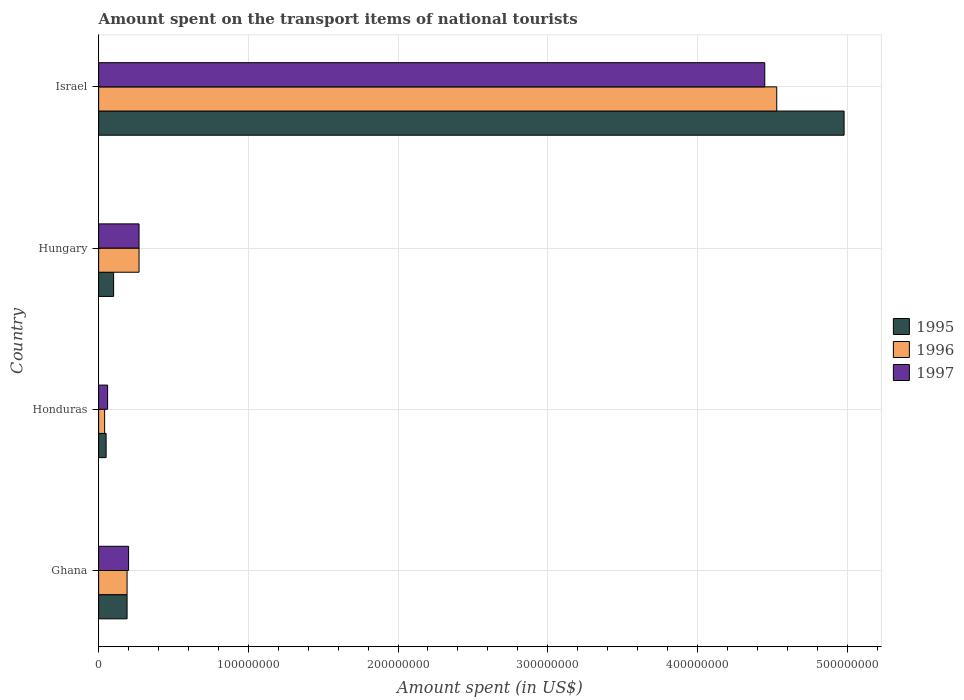How many different coloured bars are there?
Your answer should be compact. 3. How many bars are there on the 3rd tick from the top?
Give a very brief answer. 3. What is the label of the 4th group of bars from the top?
Provide a succinct answer. Ghana. In how many cases, is the number of bars for a given country not equal to the number of legend labels?
Offer a terse response. 0. What is the amount spent on the transport items of national tourists in 1996 in Honduras?
Provide a short and direct response. 4.00e+06. Across all countries, what is the maximum amount spent on the transport items of national tourists in 1997?
Provide a succinct answer. 4.45e+08. In which country was the amount spent on the transport items of national tourists in 1995 minimum?
Your response must be concise. Honduras. What is the total amount spent on the transport items of national tourists in 1996 in the graph?
Ensure brevity in your answer.  5.03e+08. What is the difference between the amount spent on the transport items of national tourists in 1996 in Ghana and that in Honduras?
Provide a short and direct response. 1.50e+07. What is the difference between the amount spent on the transport items of national tourists in 1996 in Honduras and the amount spent on the transport items of national tourists in 1995 in Ghana?
Your response must be concise. -1.50e+07. What is the average amount spent on the transport items of national tourists in 1996 per country?
Your answer should be compact. 1.26e+08. What is the ratio of the amount spent on the transport items of national tourists in 1997 in Honduras to that in Israel?
Offer a terse response. 0.01. Is the amount spent on the transport items of national tourists in 1997 in Honduras less than that in Hungary?
Your response must be concise. Yes. What is the difference between the highest and the second highest amount spent on the transport items of national tourists in 1997?
Your answer should be compact. 4.18e+08. What is the difference between the highest and the lowest amount spent on the transport items of national tourists in 1997?
Your answer should be very brief. 4.39e+08. What does the 2nd bar from the bottom in Ghana represents?
Your answer should be compact. 1996. Is it the case that in every country, the sum of the amount spent on the transport items of national tourists in 1996 and amount spent on the transport items of national tourists in 1997 is greater than the amount spent on the transport items of national tourists in 1995?
Provide a short and direct response. Yes. Are all the bars in the graph horizontal?
Keep it short and to the point. Yes. How many countries are there in the graph?
Ensure brevity in your answer.  4. Does the graph contain grids?
Provide a succinct answer. Yes. Where does the legend appear in the graph?
Your answer should be compact. Center right. What is the title of the graph?
Provide a short and direct response. Amount spent on the transport items of national tourists. Does "1982" appear as one of the legend labels in the graph?
Provide a succinct answer. No. What is the label or title of the X-axis?
Offer a very short reply. Amount spent (in US$). What is the Amount spent (in US$) of 1995 in Ghana?
Provide a short and direct response. 1.90e+07. What is the Amount spent (in US$) in 1996 in Ghana?
Give a very brief answer. 1.90e+07. What is the Amount spent (in US$) in 1995 in Honduras?
Provide a short and direct response. 5.00e+06. What is the Amount spent (in US$) of 1996 in Hungary?
Make the answer very short. 2.70e+07. What is the Amount spent (in US$) of 1997 in Hungary?
Your response must be concise. 2.70e+07. What is the Amount spent (in US$) of 1995 in Israel?
Offer a terse response. 4.98e+08. What is the Amount spent (in US$) of 1996 in Israel?
Offer a terse response. 4.53e+08. What is the Amount spent (in US$) of 1997 in Israel?
Offer a very short reply. 4.45e+08. Across all countries, what is the maximum Amount spent (in US$) of 1995?
Your answer should be very brief. 4.98e+08. Across all countries, what is the maximum Amount spent (in US$) of 1996?
Your answer should be compact. 4.53e+08. Across all countries, what is the maximum Amount spent (in US$) of 1997?
Your response must be concise. 4.45e+08. Across all countries, what is the minimum Amount spent (in US$) of 1997?
Provide a succinct answer. 6.00e+06. What is the total Amount spent (in US$) of 1995 in the graph?
Keep it short and to the point. 5.32e+08. What is the total Amount spent (in US$) in 1996 in the graph?
Give a very brief answer. 5.03e+08. What is the total Amount spent (in US$) of 1997 in the graph?
Your answer should be very brief. 4.98e+08. What is the difference between the Amount spent (in US$) of 1995 in Ghana and that in Honduras?
Your answer should be compact. 1.40e+07. What is the difference between the Amount spent (in US$) in 1996 in Ghana and that in Honduras?
Ensure brevity in your answer.  1.50e+07. What is the difference between the Amount spent (in US$) of 1997 in Ghana and that in Honduras?
Give a very brief answer. 1.40e+07. What is the difference between the Amount spent (in US$) of 1995 in Ghana and that in Hungary?
Keep it short and to the point. 9.00e+06. What is the difference between the Amount spent (in US$) in 1996 in Ghana and that in Hungary?
Provide a short and direct response. -8.00e+06. What is the difference between the Amount spent (in US$) in 1997 in Ghana and that in Hungary?
Make the answer very short. -7.00e+06. What is the difference between the Amount spent (in US$) in 1995 in Ghana and that in Israel?
Ensure brevity in your answer.  -4.79e+08. What is the difference between the Amount spent (in US$) of 1996 in Ghana and that in Israel?
Give a very brief answer. -4.34e+08. What is the difference between the Amount spent (in US$) of 1997 in Ghana and that in Israel?
Ensure brevity in your answer.  -4.25e+08. What is the difference between the Amount spent (in US$) of 1995 in Honduras and that in Hungary?
Your answer should be compact. -5.00e+06. What is the difference between the Amount spent (in US$) of 1996 in Honduras and that in Hungary?
Your answer should be compact. -2.30e+07. What is the difference between the Amount spent (in US$) in 1997 in Honduras and that in Hungary?
Give a very brief answer. -2.10e+07. What is the difference between the Amount spent (in US$) of 1995 in Honduras and that in Israel?
Your response must be concise. -4.93e+08. What is the difference between the Amount spent (in US$) of 1996 in Honduras and that in Israel?
Ensure brevity in your answer.  -4.49e+08. What is the difference between the Amount spent (in US$) in 1997 in Honduras and that in Israel?
Your response must be concise. -4.39e+08. What is the difference between the Amount spent (in US$) of 1995 in Hungary and that in Israel?
Give a very brief answer. -4.88e+08. What is the difference between the Amount spent (in US$) in 1996 in Hungary and that in Israel?
Offer a terse response. -4.26e+08. What is the difference between the Amount spent (in US$) in 1997 in Hungary and that in Israel?
Your response must be concise. -4.18e+08. What is the difference between the Amount spent (in US$) of 1995 in Ghana and the Amount spent (in US$) of 1996 in Honduras?
Give a very brief answer. 1.50e+07. What is the difference between the Amount spent (in US$) in 1995 in Ghana and the Amount spent (in US$) in 1997 in Honduras?
Give a very brief answer. 1.30e+07. What is the difference between the Amount spent (in US$) in 1996 in Ghana and the Amount spent (in US$) in 1997 in Honduras?
Make the answer very short. 1.30e+07. What is the difference between the Amount spent (in US$) in 1995 in Ghana and the Amount spent (in US$) in 1996 in Hungary?
Give a very brief answer. -8.00e+06. What is the difference between the Amount spent (in US$) in 1995 in Ghana and the Amount spent (in US$) in 1997 in Hungary?
Your answer should be compact. -8.00e+06. What is the difference between the Amount spent (in US$) of 1996 in Ghana and the Amount spent (in US$) of 1997 in Hungary?
Ensure brevity in your answer.  -8.00e+06. What is the difference between the Amount spent (in US$) of 1995 in Ghana and the Amount spent (in US$) of 1996 in Israel?
Your answer should be very brief. -4.34e+08. What is the difference between the Amount spent (in US$) of 1995 in Ghana and the Amount spent (in US$) of 1997 in Israel?
Make the answer very short. -4.26e+08. What is the difference between the Amount spent (in US$) in 1996 in Ghana and the Amount spent (in US$) in 1997 in Israel?
Offer a terse response. -4.26e+08. What is the difference between the Amount spent (in US$) in 1995 in Honduras and the Amount spent (in US$) in 1996 in Hungary?
Your response must be concise. -2.20e+07. What is the difference between the Amount spent (in US$) in 1995 in Honduras and the Amount spent (in US$) in 1997 in Hungary?
Your answer should be compact. -2.20e+07. What is the difference between the Amount spent (in US$) of 1996 in Honduras and the Amount spent (in US$) of 1997 in Hungary?
Keep it short and to the point. -2.30e+07. What is the difference between the Amount spent (in US$) in 1995 in Honduras and the Amount spent (in US$) in 1996 in Israel?
Give a very brief answer. -4.48e+08. What is the difference between the Amount spent (in US$) of 1995 in Honduras and the Amount spent (in US$) of 1997 in Israel?
Offer a terse response. -4.40e+08. What is the difference between the Amount spent (in US$) in 1996 in Honduras and the Amount spent (in US$) in 1997 in Israel?
Keep it short and to the point. -4.41e+08. What is the difference between the Amount spent (in US$) of 1995 in Hungary and the Amount spent (in US$) of 1996 in Israel?
Provide a short and direct response. -4.43e+08. What is the difference between the Amount spent (in US$) of 1995 in Hungary and the Amount spent (in US$) of 1997 in Israel?
Your answer should be compact. -4.35e+08. What is the difference between the Amount spent (in US$) in 1996 in Hungary and the Amount spent (in US$) in 1997 in Israel?
Offer a terse response. -4.18e+08. What is the average Amount spent (in US$) in 1995 per country?
Your response must be concise. 1.33e+08. What is the average Amount spent (in US$) in 1996 per country?
Give a very brief answer. 1.26e+08. What is the average Amount spent (in US$) in 1997 per country?
Your response must be concise. 1.24e+08. What is the difference between the Amount spent (in US$) in 1995 and Amount spent (in US$) in 1996 in Ghana?
Provide a succinct answer. 0. What is the difference between the Amount spent (in US$) in 1995 and Amount spent (in US$) in 1997 in Ghana?
Provide a short and direct response. -1.00e+06. What is the difference between the Amount spent (in US$) of 1995 and Amount spent (in US$) of 1997 in Honduras?
Provide a short and direct response. -1.00e+06. What is the difference between the Amount spent (in US$) of 1995 and Amount spent (in US$) of 1996 in Hungary?
Your response must be concise. -1.70e+07. What is the difference between the Amount spent (in US$) of 1995 and Amount spent (in US$) of 1997 in Hungary?
Keep it short and to the point. -1.70e+07. What is the difference between the Amount spent (in US$) in 1995 and Amount spent (in US$) in 1996 in Israel?
Offer a very short reply. 4.50e+07. What is the difference between the Amount spent (in US$) in 1995 and Amount spent (in US$) in 1997 in Israel?
Your response must be concise. 5.30e+07. What is the difference between the Amount spent (in US$) in 1996 and Amount spent (in US$) in 1997 in Israel?
Offer a very short reply. 8.00e+06. What is the ratio of the Amount spent (in US$) in 1995 in Ghana to that in Honduras?
Your response must be concise. 3.8. What is the ratio of the Amount spent (in US$) in 1996 in Ghana to that in Honduras?
Your answer should be very brief. 4.75. What is the ratio of the Amount spent (in US$) of 1996 in Ghana to that in Hungary?
Ensure brevity in your answer.  0.7. What is the ratio of the Amount spent (in US$) in 1997 in Ghana to that in Hungary?
Your answer should be compact. 0.74. What is the ratio of the Amount spent (in US$) of 1995 in Ghana to that in Israel?
Offer a very short reply. 0.04. What is the ratio of the Amount spent (in US$) of 1996 in Ghana to that in Israel?
Offer a very short reply. 0.04. What is the ratio of the Amount spent (in US$) in 1997 in Ghana to that in Israel?
Your answer should be compact. 0.04. What is the ratio of the Amount spent (in US$) of 1996 in Honduras to that in Hungary?
Your answer should be compact. 0.15. What is the ratio of the Amount spent (in US$) of 1997 in Honduras to that in Hungary?
Your answer should be very brief. 0.22. What is the ratio of the Amount spent (in US$) of 1995 in Honduras to that in Israel?
Offer a very short reply. 0.01. What is the ratio of the Amount spent (in US$) in 1996 in Honduras to that in Israel?
Offer a very short reply. 0.01. What is the ratio of the Amount spent (in US$) in 1997 in Honduras to that in Israel?
Ensure brevity in your answer.  0.01. What is the ratio of the Amount spent (in US$) of 1995 in Hungary to that in Israel?
Offer a terse response. 0.02. What is the ratio of the Amount spent (in US$) of 1996 in Hungary to that in Israel?
Provide a short and direct response. 0.06. What is the ratio of the Amount spent (in US$) of 1997 in Hungary to that in Israel?
Give a very brief answer. 0.06. What is the difference between the highest and the second highest Amount spent (in US$) in 1995?
Your answer should be very brief. 4.79e+08. What is the difference between the highest and the second highest Amount spent (in US$) of 1996?
Keep it short and to the point. 4.26e+08. What is the difference between the highest and the second highest Amount spent (in US$) of 1997?
Ensure brevity in your answer.  4.18e+08. What is the difference between the highest and the lowest Amount spent (in US$) in 1995?
Your answer should be compact. 4.93e+08. What is the difference between the highest and the lowest Amount spent (in US$) of 1996?
Provide a short and direct response. 4.49e+08. What is the difference between the highest and the lowest Amount spent (in US$) of 1997?
Keep it short and to the point. 4.39e+08. 